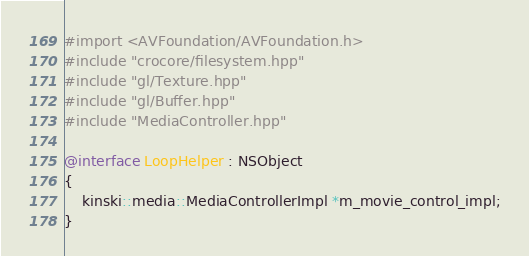Convert code to text. <code><loc_0><loc_0><loc_500><loc_500><_ObjectiveC_>#import <AVFoundation/AVFoundation.h>
#include "crocore/filesystem.hpp"
#include "gl/Texture.hpp"
#include "gl/Buffer.hpp"
#include "MediaController.hpp"

@interface LoopHelper : NSObject
{
    kinski::media::MediaControllerImpl *m_movie_control_impl;
}</code> 